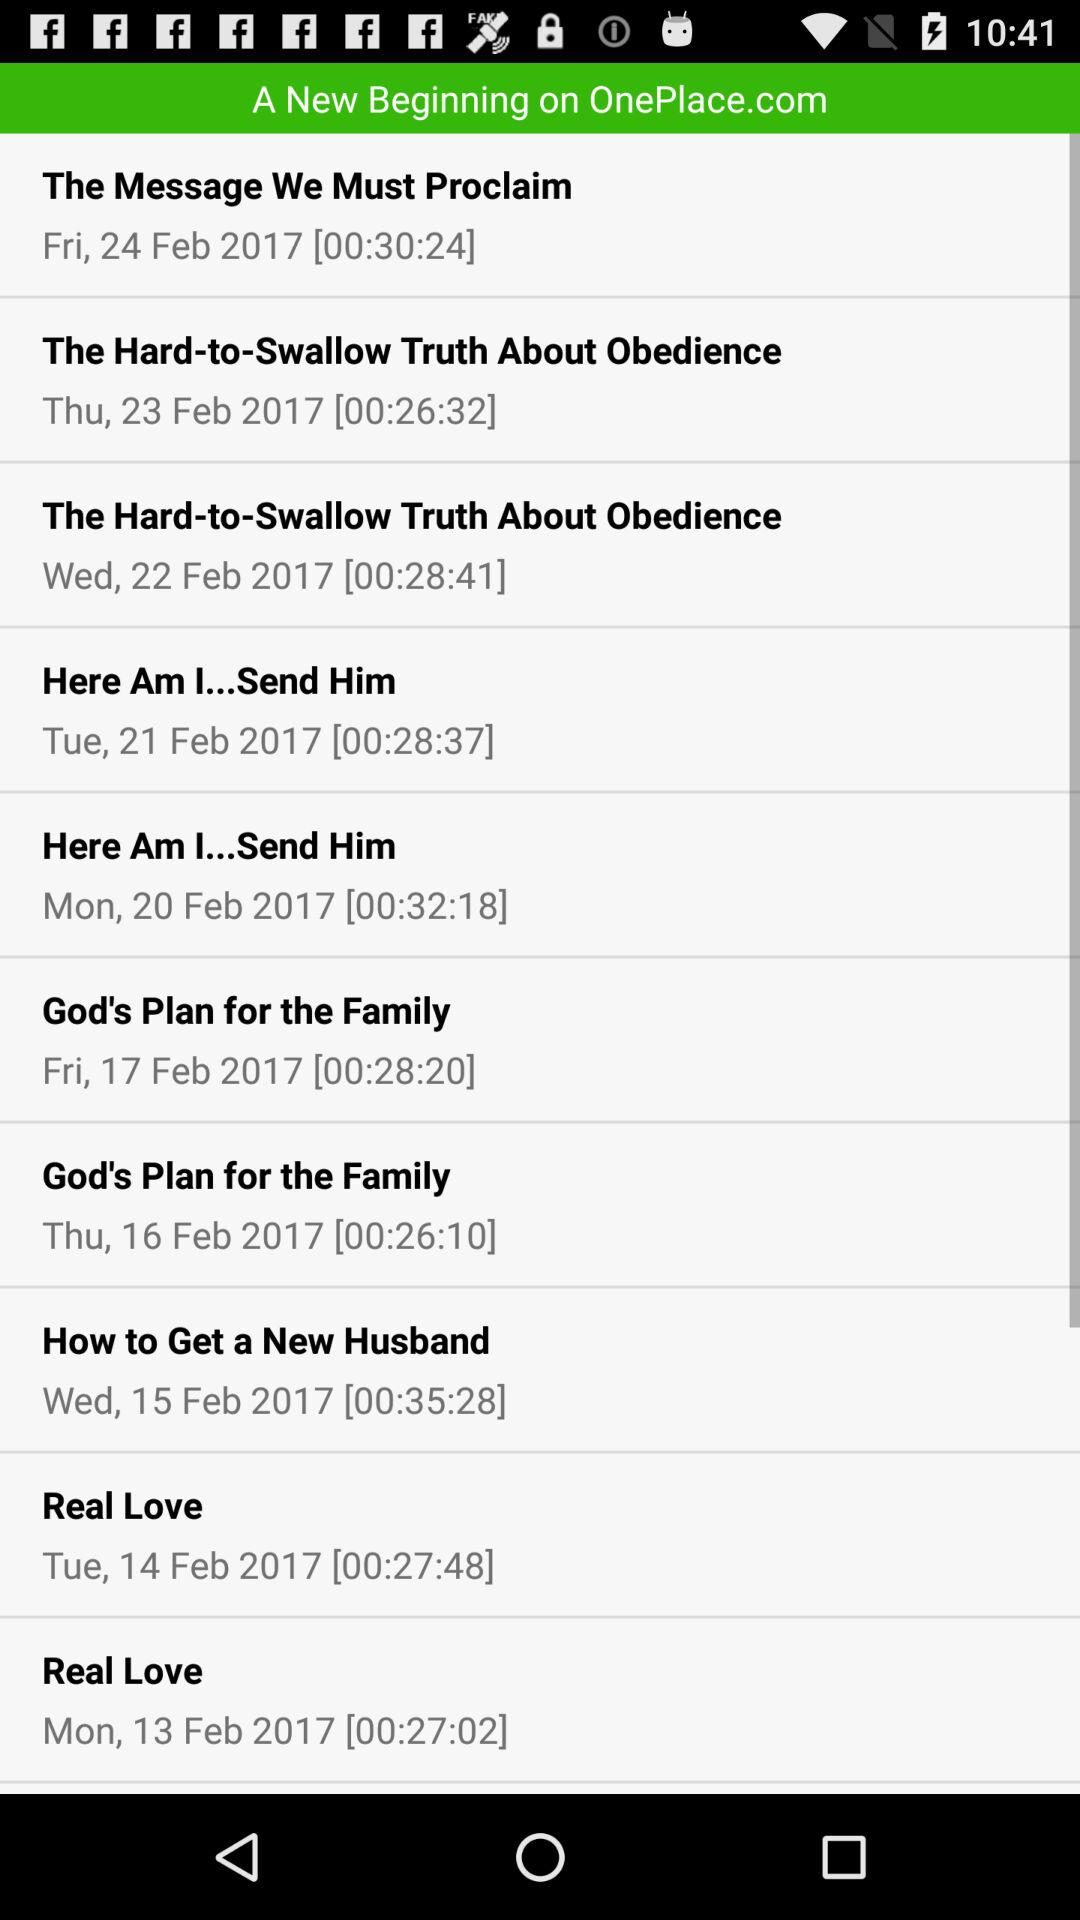Who sang "Here Am I...Send Him"?
When the provided information is insufficient, respond with <no answer>. <no answer> 